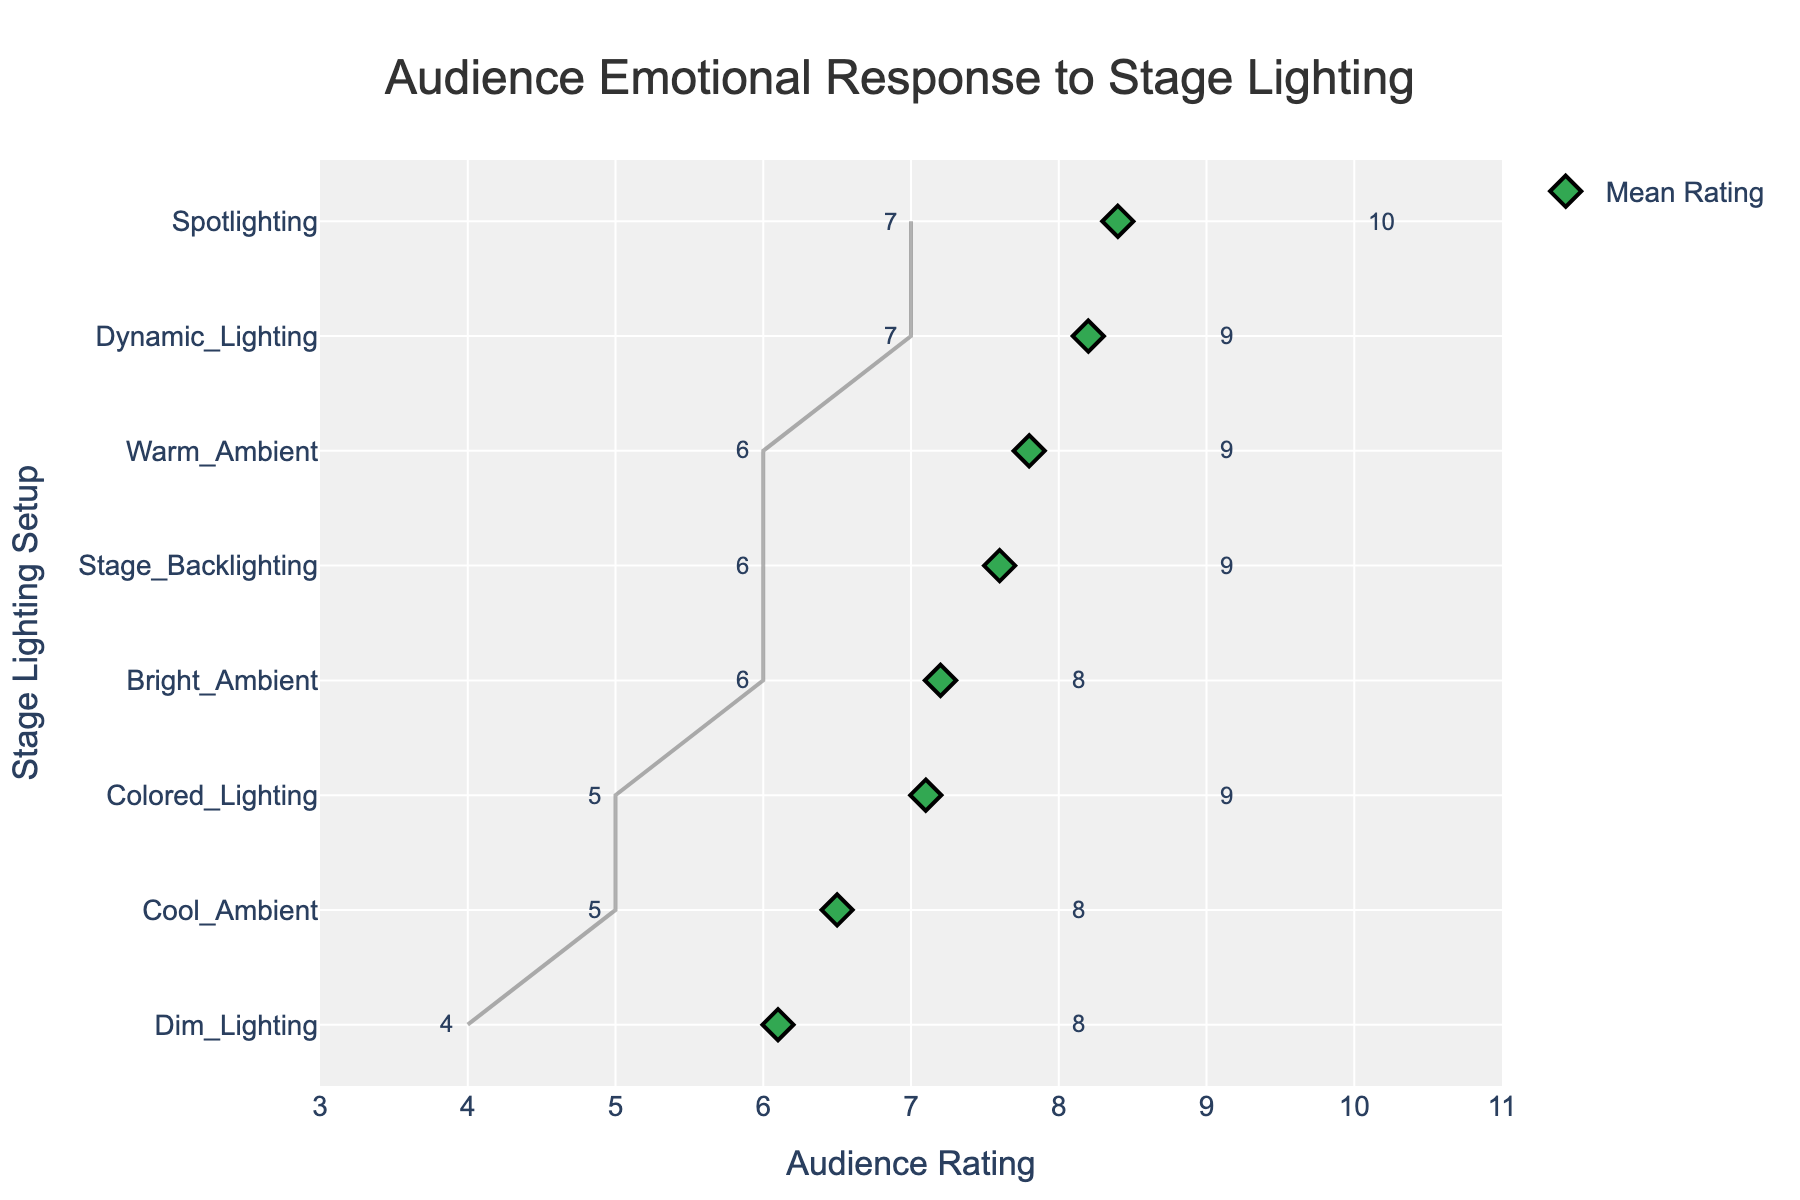Which stage lighting setup received the highest mean audience rating? The highest mean audience rating can be identified by looking for the lighting setup associated with the highest point on the horizontal axis. The spotlighting setup has a mean rating of 8.4, which is the highest.
Answer: Spotlighting What is the range of audience ratings for the Cool Ambient lighting setup? The range is calculated by finding the difference between the maximum and minimum audience ratings for the Cool Ambient setup. The min rating is 5 and the max rating is 8, so the range is 8 - 5 = 3.
Answer: 3 Which lighting setup has the smallest range of audience ratings? The smallest range is identified by finding the lighting setup with the smallest difference between its max and min ratings. Warm Ambient has ratings from 6 to 9, so 9 - 6 = 3. However, other setups should be checked too. Upon review, Spotlighting also has a range, from 7 to 10, which is similarly 3. No setup has a range smaller than 3.
Answer: Warm Ambient, Spotlighting How does the audience rating of Dim Lighting compare to Dynamic Lighting in terms of their mean values? Compare the mean values of both setups: Dim Lighting has a mean rating of 6.1, whereas Dynamic Lighting has a mean rating of 8.2. Therefore, Dynamic Lighting has a higher mean rating than Dim Lighting.
Answer: Dynamic Lighting is higher What is the mean audience rating for Colored Lighting? The mean audience rating for Colored Lighting can be directly read from the plot where the mean for this setup is marked. The mean rating for Colored Lighting is 7.1.
Answer: 7.1 Which stage lighting setup has the largest spread between min and max ratings, and what is that spread? The setup with the largest spread will have the maximum difference between its min and max ratings. Dim Lighting ranges from 4 to 8 which makes 8 - 4 = 4. No other setup has a wider range.
Answer: Dim Lighting, 4 What is the combined mean audience rating for Warm Ambient and Cool Ambient setups? Add the mean ratings of Warm Ambient (7.8) and Cool Ambient (6.5). The combined mean is 7.8 + 6.5 = 14.3.
Answer: 14.3 Which lighting setups have a mean rating above 7? Identify setups where the mean rating exceeds 7 by looking at the diamond markers on the plot exceeding the 7 rating mark. Warm Ambient, Bright Ambient, Spotlighting, Colored Lighting, Dynamic Lighting, and Stage Backlighting all have mean ratings above 7.
Answer: Warm Ambient, Bright Ambient, Spotlighting, Colored Lighting, Dynamic Lighting, Stage Backlighting 